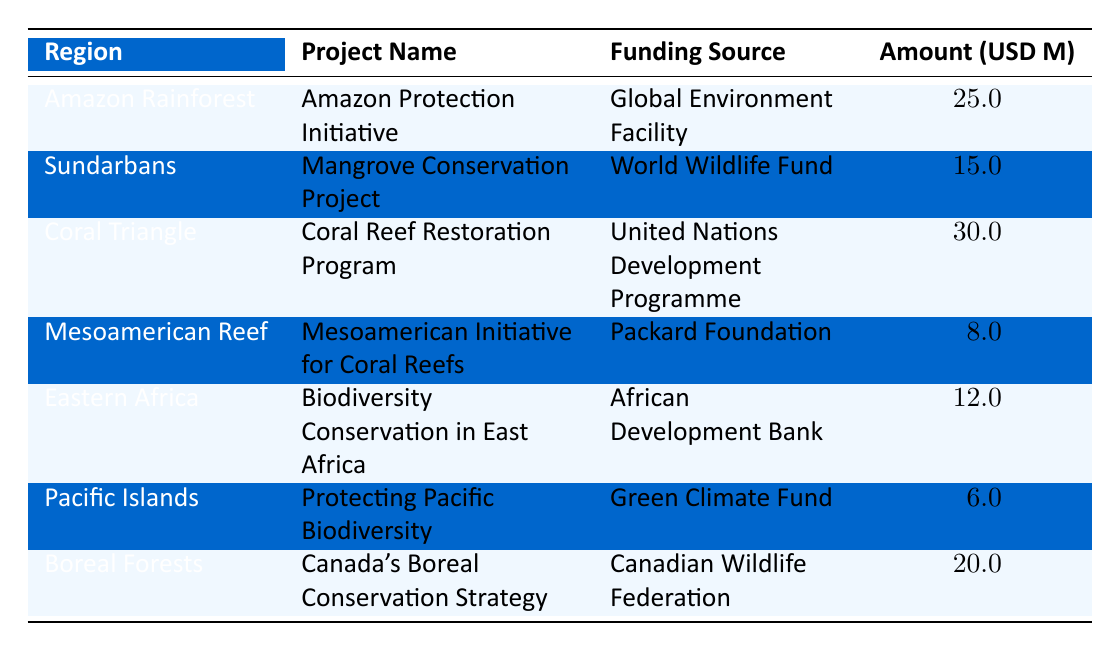What is the total funding allocated for the Coral Triangle in 2022? The table shows that the funding amount for the Coral Triangle, specifically for the Coral Reef Restoration Program, is 30 million USD.
Answer: 30 million USD Which region received the least amount of funding? By comparing the funding amounts listed in the table, it can be seen that the Pacific Islands received the least funding, totaling 6 million USD.
Answer: Pacific Islands Is the funding source for the Amazon Rainforest the Global Environment Facility? According to the table, the Amazon Protection Initiative, which is for the Amazon Rainforest, is indeed funded by the Global Environment Facility.
Answer: Yes What is the combined funding amount for projects in Eastern Africa and the Sundarbans? The funding for Eastern Africa is 12 million USD and for the Sundarbans is 15 million USD. Adding these amounts together gives 12 + 15 = 27 million USD.
Answer: 27 million USD How many regions received more than 20 million USD in funding? The regions that received more than 20 million USD in funding are the Amazon Rainforest (25 million USD) and the Coral Triangle (30 million USD). This gives a total of 2 regions.
Answer: 2 regions What is the average funding amount for all listed projects? The total funding amounts for all listed projects is 25000000 + 15000000 + 30000000 + 8000000 + 12000000 + 6000000 + 20000000 =  1.515 billion USD. There are 7 projects in total, so the average is calculated as 1515000000 / 7 = approximately 216428571.43.
Answer: Approximately 216.43 million USD Did the Mesoamerican Reef project receive more funding than the Pacific Islands project? The table indicates that the Mesoamerican Initiative for Coral Reefs received 8 million USD and the Protecting Pacific Biodiversity project received 6 million USD. Thus, the Mesoamerican Reef project received more funding.
Answer: Yes Which project among those listed received funding from the World Wildlife Fund? Referring to the table, it shows that the Mangrove Conservation Project is the one that received funding from the World Wildlife Fund, which is specifically for the Sundarbans region.
Answer: Mangrove Conservation Project 